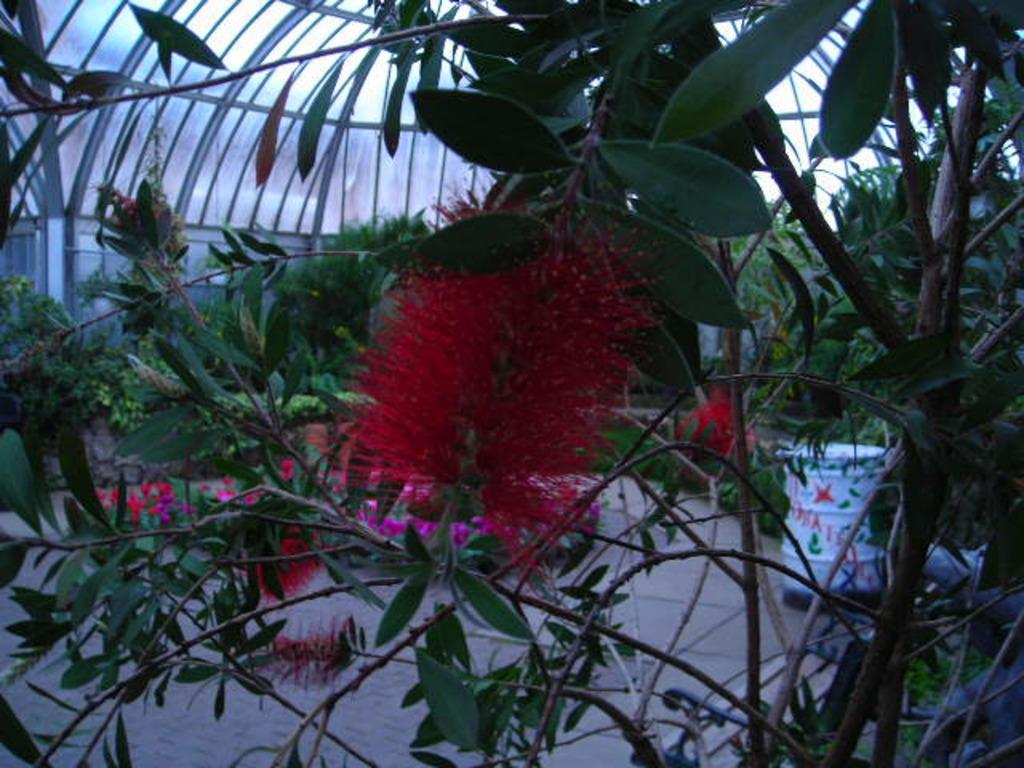What can be seen in the foreground of the image? There are flowers and plants in the foreground of the image. What is visible in the background of the image? There are plants and trees in the background of the image. What is the ceiling like in the image? The top of the image features a ceiling. What book is the wave reading in the image? There is no wave or book present in the image; it features flowers, plants, and trees. 